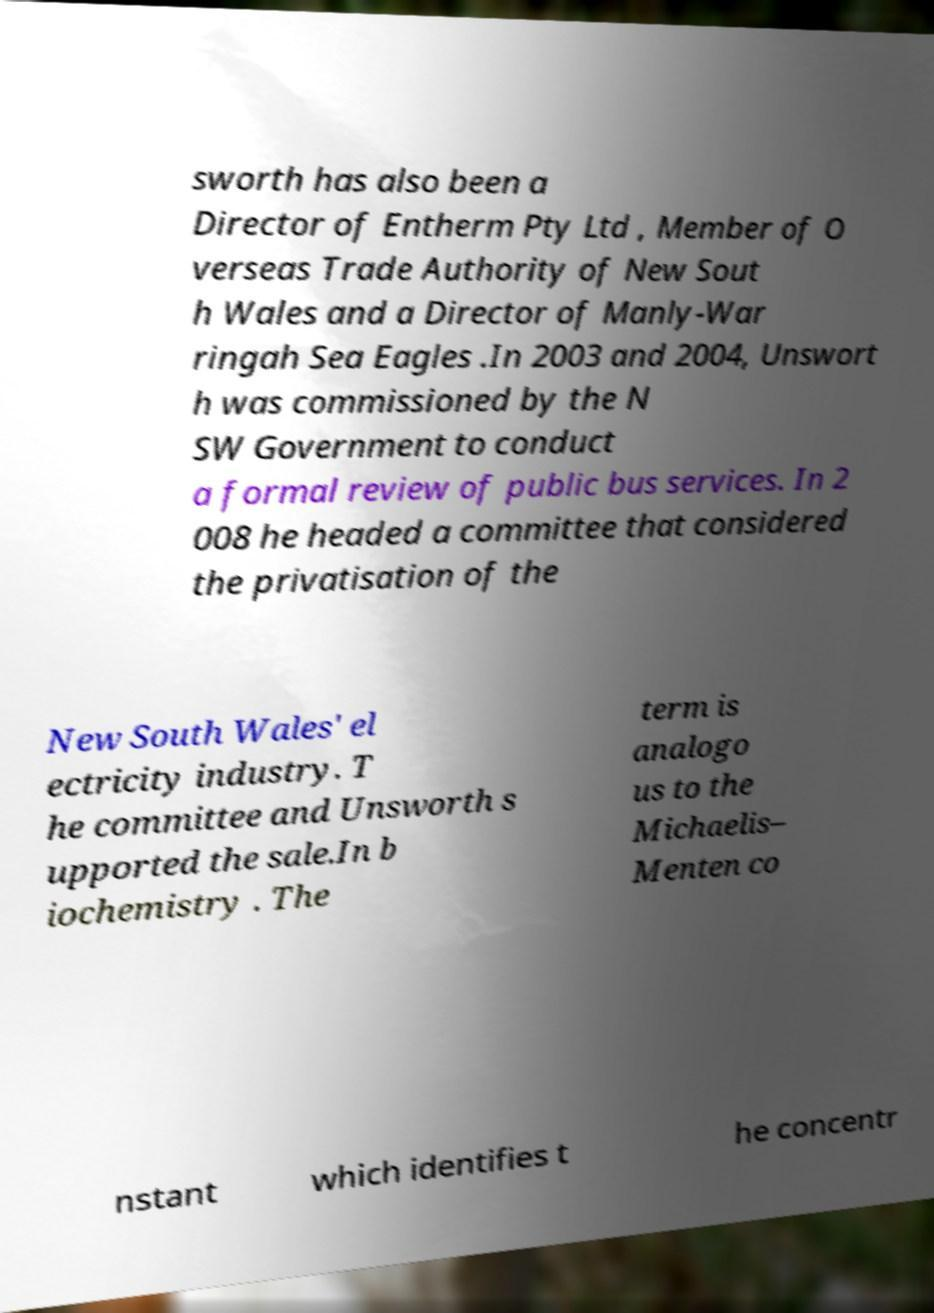I need the written content from this picture converted into text. Can you do that? sworth has also been a Director of Entherm Pty Ltd , Member of O verseas Trade Authority of New Sout h Wales and a Director of Manly-War ringah Sea Eagles .In 2003 and 2004, Unswort h was commissioned by the N SW Government to conduct a formal review of public bus services. In 2 008 he headed a committee that considered the privatisation of the New South Wales' el ectricity industry. T he committee and Unsworth s upported the sale.In b iochemistry . The term is analogo us to the Michaelis– Menten co nstant which identifies t he concentr 